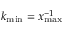<formula> <loc_0><loc_0><loc_500><loc_500>k _ { \min } = x _ { \max } ^ { - 1 }</formula> 